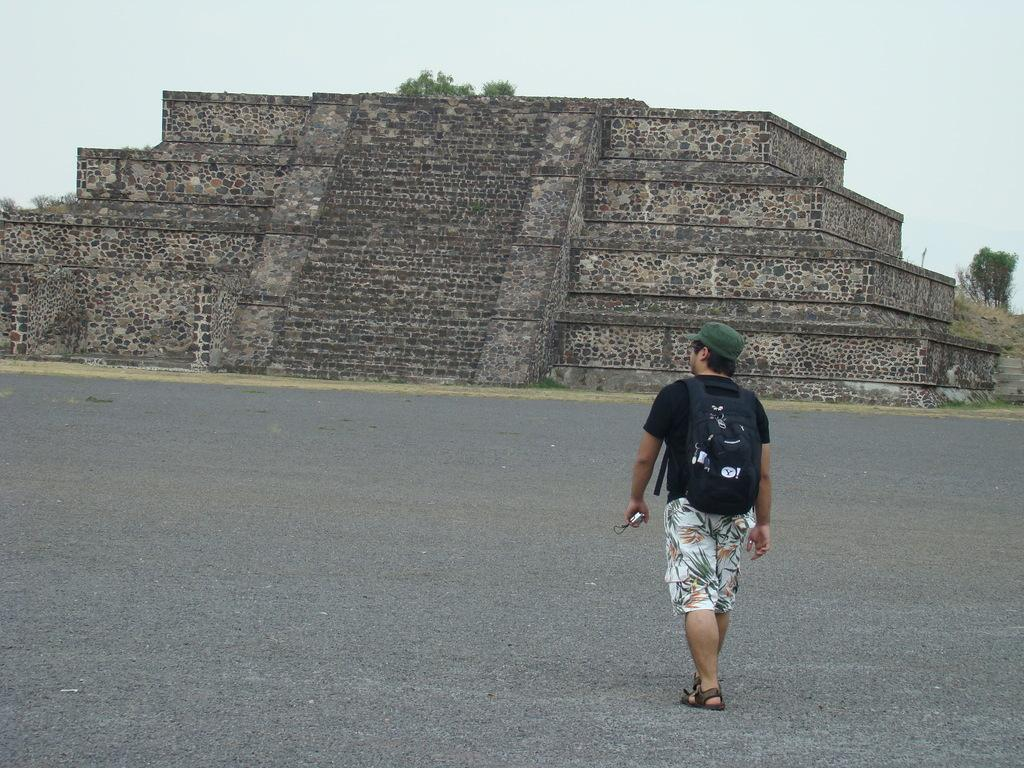Where was the image taken? The image was taken outside. What can be seen on the right side of the image? There are trees on the right side of the image. What is visible at the top of the image? The sky is visible at the top of the image. What is the person in the middle of the image doing? The person is walking in the middle of the image. What accessories is the person wearing? The person is wearing a backpack and a cap. Where is the faucet located in the image? There is no faucet present in the image. What type of sticks are being used by the person in the image? There are no sticks visible in the image; the person is wearing a backpack and a cap. 